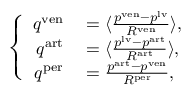Convert formula to latex. <formula><loc_0><loc_0><loc_500><loc_500>\left \{ \begin{array} { r l } { q ^ { v e n } } & = \langle \frac { p ^ { v e n } - p ^ { l v } } { R ^ { v e n } } \rangle , } \\ { q ^ { a r t } } & = \langle \frac { p ^ { l v } - p ^ { a r t } } { R ^ { a r t } } \rangle , } \\ { q ^ { p e r } } & = \frac { p ^ { a r t } - p ^ { v e n } } { R ^ { p e r } } , } \end{array}</formula> 